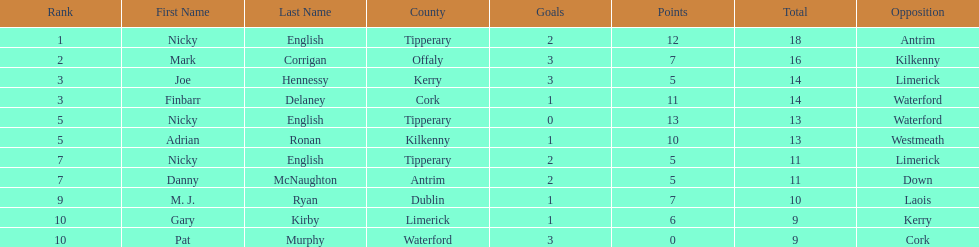How many times was waterford the opposition? 2. 